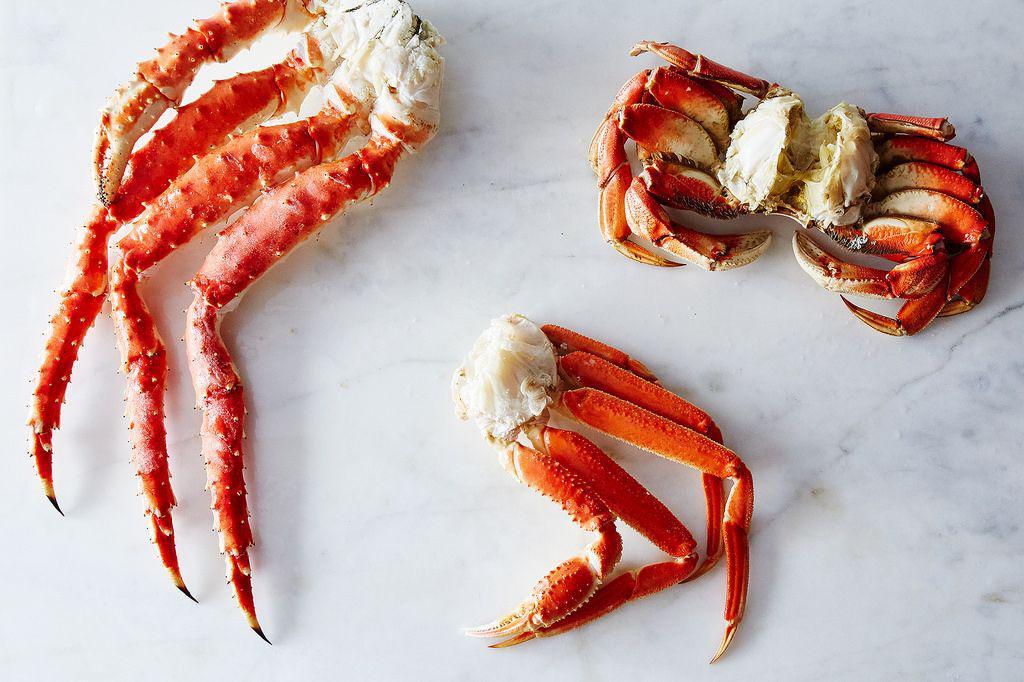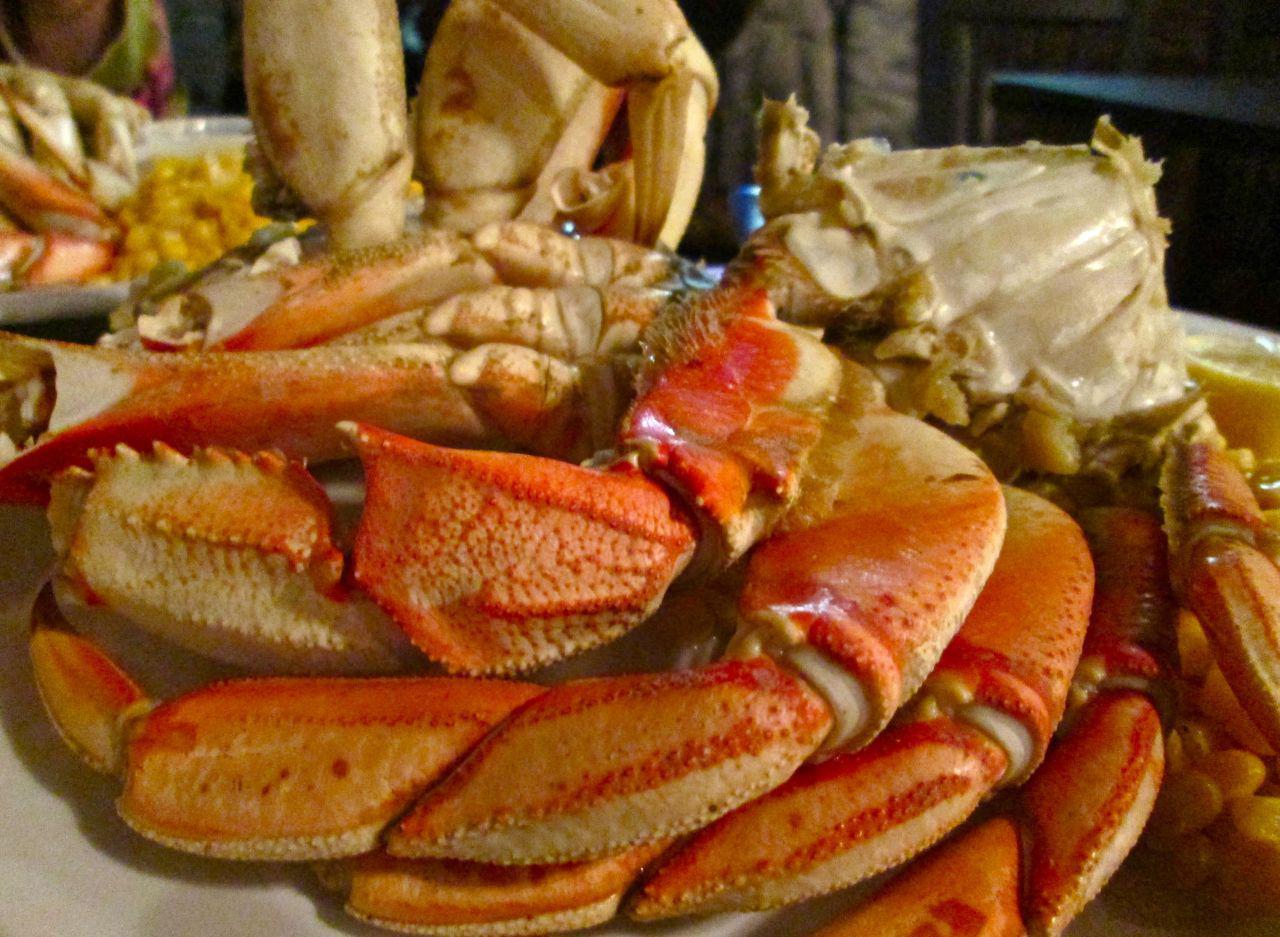The first image is the image on the left, the second image is the image on the right. Given the left and right images, does the statement "At least one of the images includes a small white dish of dipping sauce next to the plate of crab." hold true? Answer yes or no. No. The first image is the image on the left, the second image is the image on the right. Considering the images on both sides, is "There is food other than crab in both images." valid? Answer yes or no. No. 